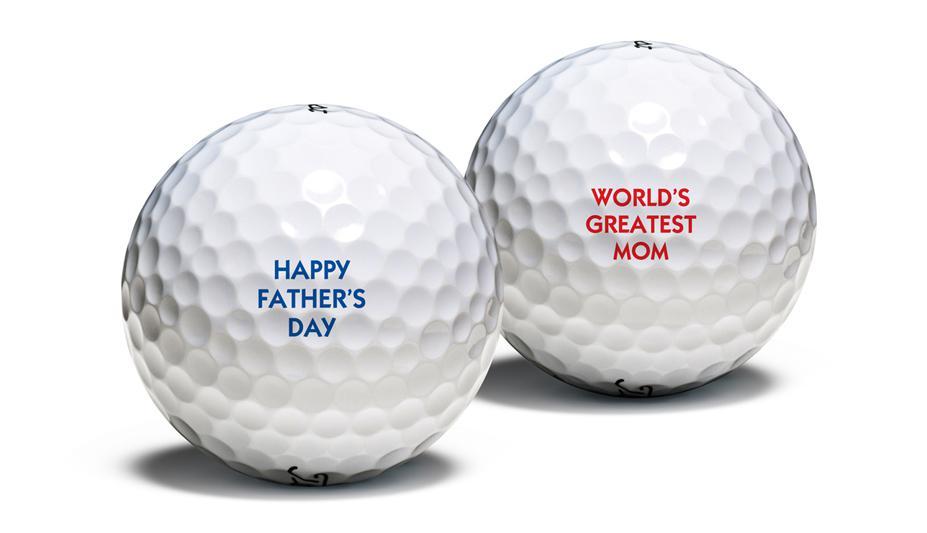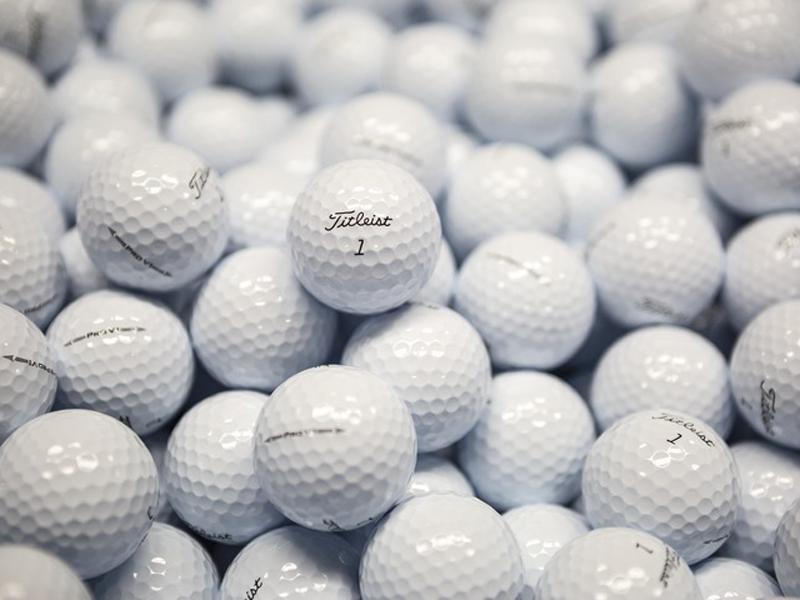The first image is the image on the left, the second image is the image on the right. Considering the images on both sides, is "Only one golf ball is depicted on at least one image." valid? Answer yes or no. No. The first image is the image on the left, the second image is the image on the right. Examine the images to the left and right. Is the description "At least one image has exactly one golf ball." accurate? Answer yes or no. No. 